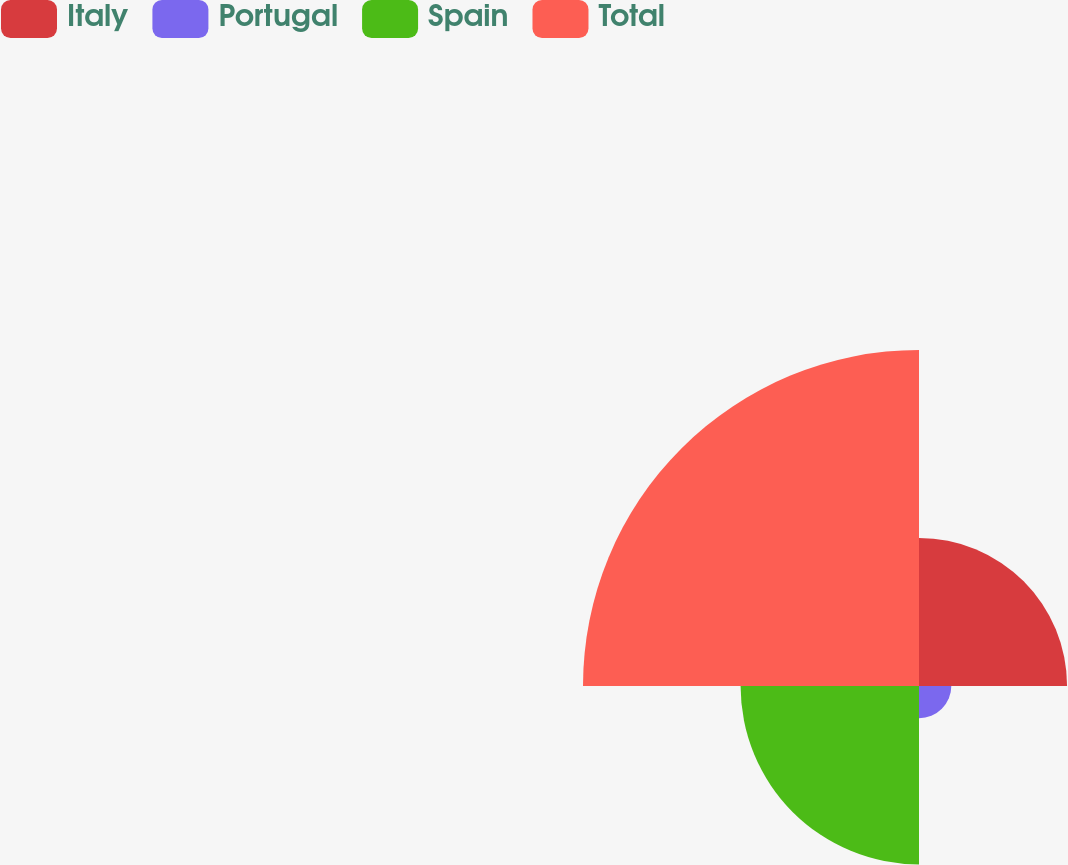Convert chart to OTSL. <chart><loc_0><loc_0><loc_500><loc_500><pie_chart><fcel>Italy<fcel>Portugal<fcel>Spain<fcel>Total<nl><fcel>21.31%<fcel>4.65%<fcel>25.68%<fcel>48.36%<nl></chart> 